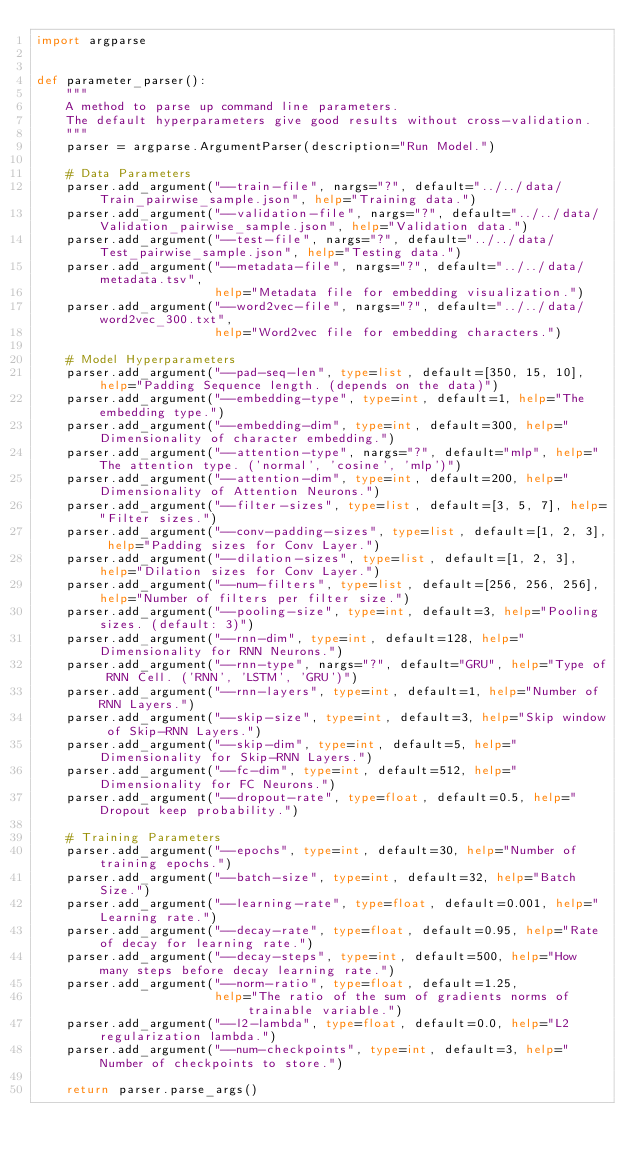<code> <loc_0><loc_0><loc_500><loc_500><_Python_>import argparse


def parameter_parser():
    """
    A method to parse up command line parameters.
    The default hyperparameters give good results without cross-validation.
    """
    parser = argparse.ArgumentParser(description="Run Model.")

    # Data Parameters
    parser.add_argument("--train-file", nargs="?", default="../../data/Train_pairwise_sample.json", help="Training data.")
    parser.add_argument("--validation-file", nargs="?", default="../../data/Validation_pairwise_sample.json", help="Validation data.")
    parser.add_argument("--test-file", nargs="?", default="../../data/Test_pairwise_sample.json", help="Testing data.")
    parser.add_argument("--metadata-file", nargs="?", default="../../data/metadata.tsv",
                        help="Metadata file for embedding visualization.")
    parser.add_argument("--word2vec-file", nargs="?", default="../../data/word2vec_300.txt",
                        help="Word2vec file for embedding characters.")

    # Model Hyperparameters
    parser.add_argument("--pad-seq-len", type=list, default=[350, 15, 10], help="Padding Sequence length. (depends on the data)")
    parser.add_argument("--embedding-type", type=int, default=1, help="The embedding type.")
    parser.add_argument("--embedding-dim", type=int, default=300, help="Dimensionality of character embedding.")
    parser.add_argument("--attention-type", nargs="?", default="mlp", help="The attention type. ('normal', 'cosine', 'mlp')")
    parser.add_argument("--attention-dim", type=int, default=200, help="Dimensionality of Attention Neurons.")
    parser.add_argument("--filter-sizes", type=list, default=[3, 5, 7], help="Filter sizes.")
    parser.add_argument("--conv-padding-sizes", type=list, default=[1, 2, 3], help="Padding sizes for Conv Layer.")
    parser.add_argument("--dilation-sizes", type=list, default=[1, 2, 3], help="Dilation sizes for Conv Layer.")
    parser.add_argument("--num-filters", type=list, default=[256, 256, 256], help="Number of filters per filter size.")
    parser.add_argument("--pooling-size", type=int, default=3, help="Pooling sizes. (default: 3)")
    parser.add_argument("--rnn-dim", type=int, default=128, help="Dimensionality for RNN Neurons.")
    parser.add_argument("--rnn-type", nargs="?", default="GRU", help="Type of RNN Cell. ('RNN', 'LSTM', 'GRU')")
    parser.add_argument("--rnn-layers", type=int, default=1, help="Number of RNN Layers.")
    parser.add_argument("--skip-size", type=int, default=3, help="Skip window of Skip-RNN Layers.")
    parser.add_argument("--skip-dim", type=int, default=5, help="Dimensionality for Skip-RNN Layers.")
    parser.add_argument("--fc-dim", type=int, default=512, help="Dimensionality for FC Neurons.")
    parser.add_argument("--dropout-rate", type=float, default=0.5, help="Dropout keep probability.")

    # Training Parameters
    parser.add_argument("--epochs", type=int, default=30, help="Number of training epochs.")
    parser.add_argument("--batch-size", type=int, default=32, help="Batch Size.")
    parser.add_argument("--learning-rate", type=float, default=0.001, help="Learning rate.")
    parser.add_argument("--decay-rate", type=float, default=0.95, help="Rate of decay for learning rate.")
    parser.add_argument("--decay-steps", type=int, default=500, help="How many steps before decay learning rate.")
    parser.add_argument("--norm-ratio", type=float, default=1.25,
                        help="The ratio of the sum of gradients norms of trainable variable.")
    parser.add_argument("--l2-lambda", type=float, default=0.0, help="L2 regularization lambda.")
    parser.add_argument("--num-checkpoints", type=int, default=3, help="Number of checkpoints to store.")

    return parser.parse_args()</code> 